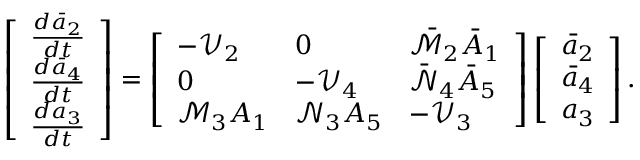<formula> <loc_0><loc_0><loc_500><loc_500>\left [ \begin{array} { l } { \frac { d \bar { a } _ { 2 } } { d t } } \\ { \frac { d \bar { a } _ { 4 } } { d t } } \\ { \frac { d { a } _ { 3 } } { d t } } \end{array} \right ] = \left [ \begin{array} { l l l } { - \mathcal { V } _ { 2 } } & { 0 } & { \bar { { \mathcal { M } } } _ { 2 } \bar { A } _ { 1 } } \\ { 0 } & { - \mathcal { V } _ { 4 } } & { \bar { \mathcal { N } } _ { 4 } \bar { A } _ { 5 } } \\ { { \mathcal { M } } _ { 3 } { A } _ { 1 } } & { { \mathcal { N } } _ { 3 } { A } _ { 5 } } & { - \mathcal { V } _ { 3 } } \end{array} \right ] \left [ \begin{array} { l } { \bar { a } _ { 2 } } \\ { \bar { a } _ { 4 } } \\ { { a } _ { 3 } } \end{array} \right ] .</formula> 